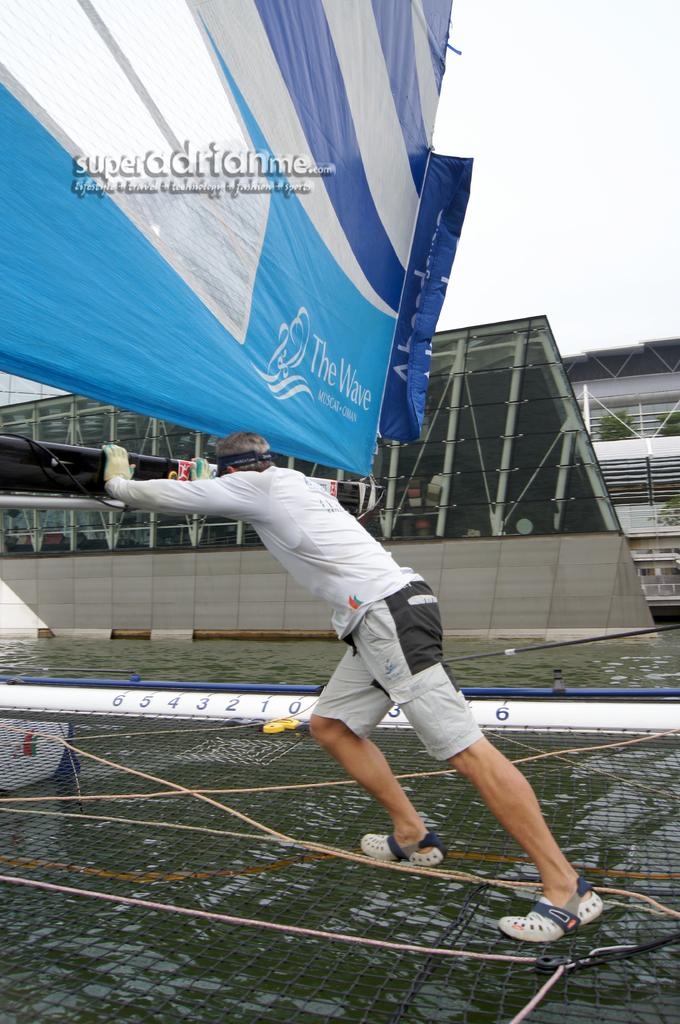What natural feature is present in the image? The image contains the sea. What is the person in the image doing? The person is pushing an object in the image. What type of signage is visible in the image? There is a big banner in the image. What type of structure can be seen in the image? There is a building in the image. What type of vegetation is present in the image? There are two plants in the image. What is on the surface in the image? There are objects on the surface in the image. What is visible at the top of the image? The sky is visible at the top of the image. What type of knowledge is being shared between the trees in the image? There are no trees present in the image, so no knowledge can be shared between them. 